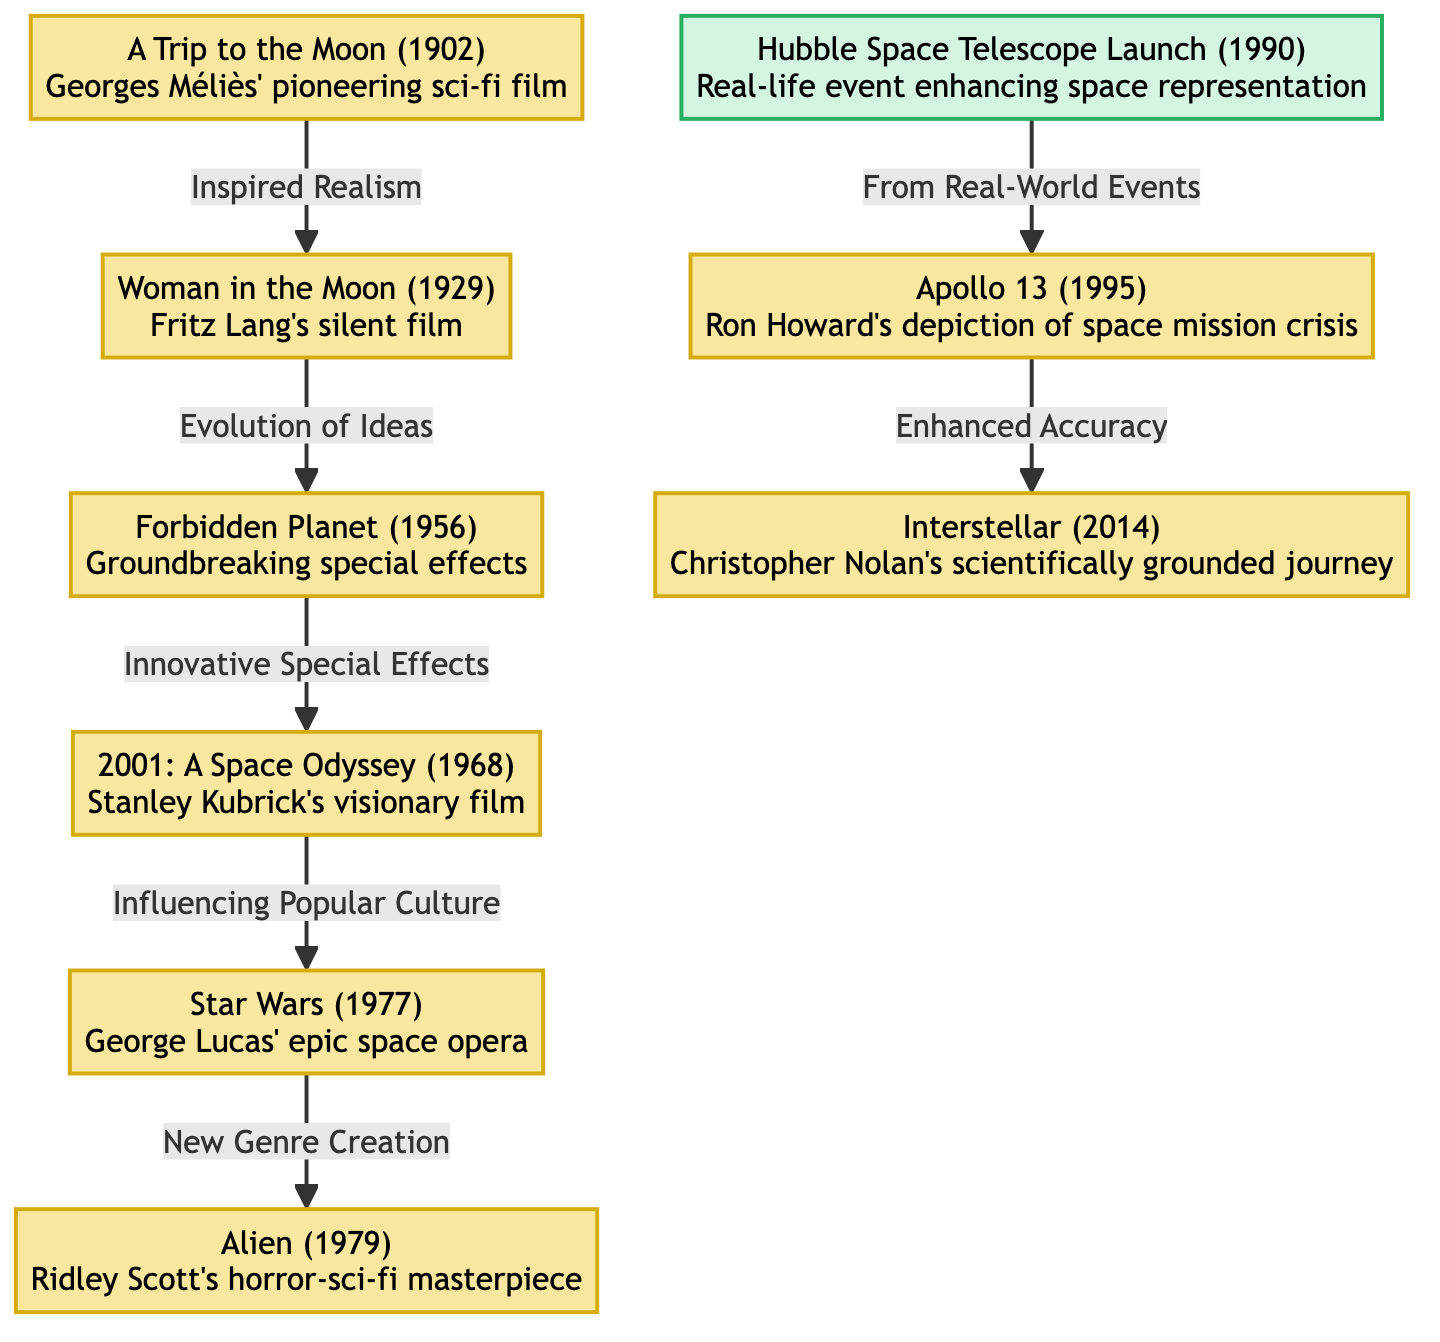What is the title of the first film in the timeline? The first film listed in the timeline is "A Trip to the Moon (1902)" by Georges Méliès. This can be identified as the starting node in the diagram, which is the only film placed at the very beginning of the flow.
Answer: A Trip to the Moon (1902) Which film follows "A Trip to the Moon"? The diagram indicates that "Woman in the Moon (1929)" is the direct next film in the lineup following "A Trip to the Moon (1902)." This is evaluated by following the arrow from the first node to the second node.
Answer: Woman in the Moon (1929) How many films are represented in the diagram? Counting the distinct nodes associated with films in the diagram, there are a total of 8 films illustrated. This involves identifying each film node while excluding the event node.
Answer: 8 What significant event is connected to "Apollo 13"? The node for "Apollo 13 (1995)" is connected to "Hubble Space Telescope Launch (1990)," which is the only event node in the diagram. This is determined by tracing the arrow leading into the Apollo 13 node.
Answer: Hubble Space Telescope Launch (1990) What does "Interstellar" signify in relation to "Apollo 13"? "Interstellar (2014)" signifies the last film that builds upon the ideas introduced in "Apollo 13 (1995)," with the connection showing a progression of enhanced accuracy in cinematic representations of space. This is figured out by following the relationship edge from Apollo 13 to Interstellar.
Answer: Enhanced Accuracy What film is described as "Ridley Scott's horror-sci-fi masterpiece"? The description "Ridley Scott's horror-sci-fi masterpiece" corresponds to the film "Alien (1979)," which is indicated as a subsequent film stemming from "Star Wars (1977)" in the diagram.
Answer: Alien (1979) Which film marks an evolution of ideas from the silent film era? The film "Woman in the Moon (1929)" is identified as the one that demonstrates the evolution of ideas following "A Trip to the Moon (1902)." This is understood by examining the arrow and label that specifies the connection between these two films.
Answer: Woman in the Moon (1929) What does the progression from "2001: A Space Odyssey" lead to? The progression from "2001: A Space Odyssey (1968)" leads to "Star Wars (1977)," showcasing its influence on popular culture. This can be traced by following the arrow from the Kubrick masterpiece node to the space opera node.
Answer: Star Wars (1977) 